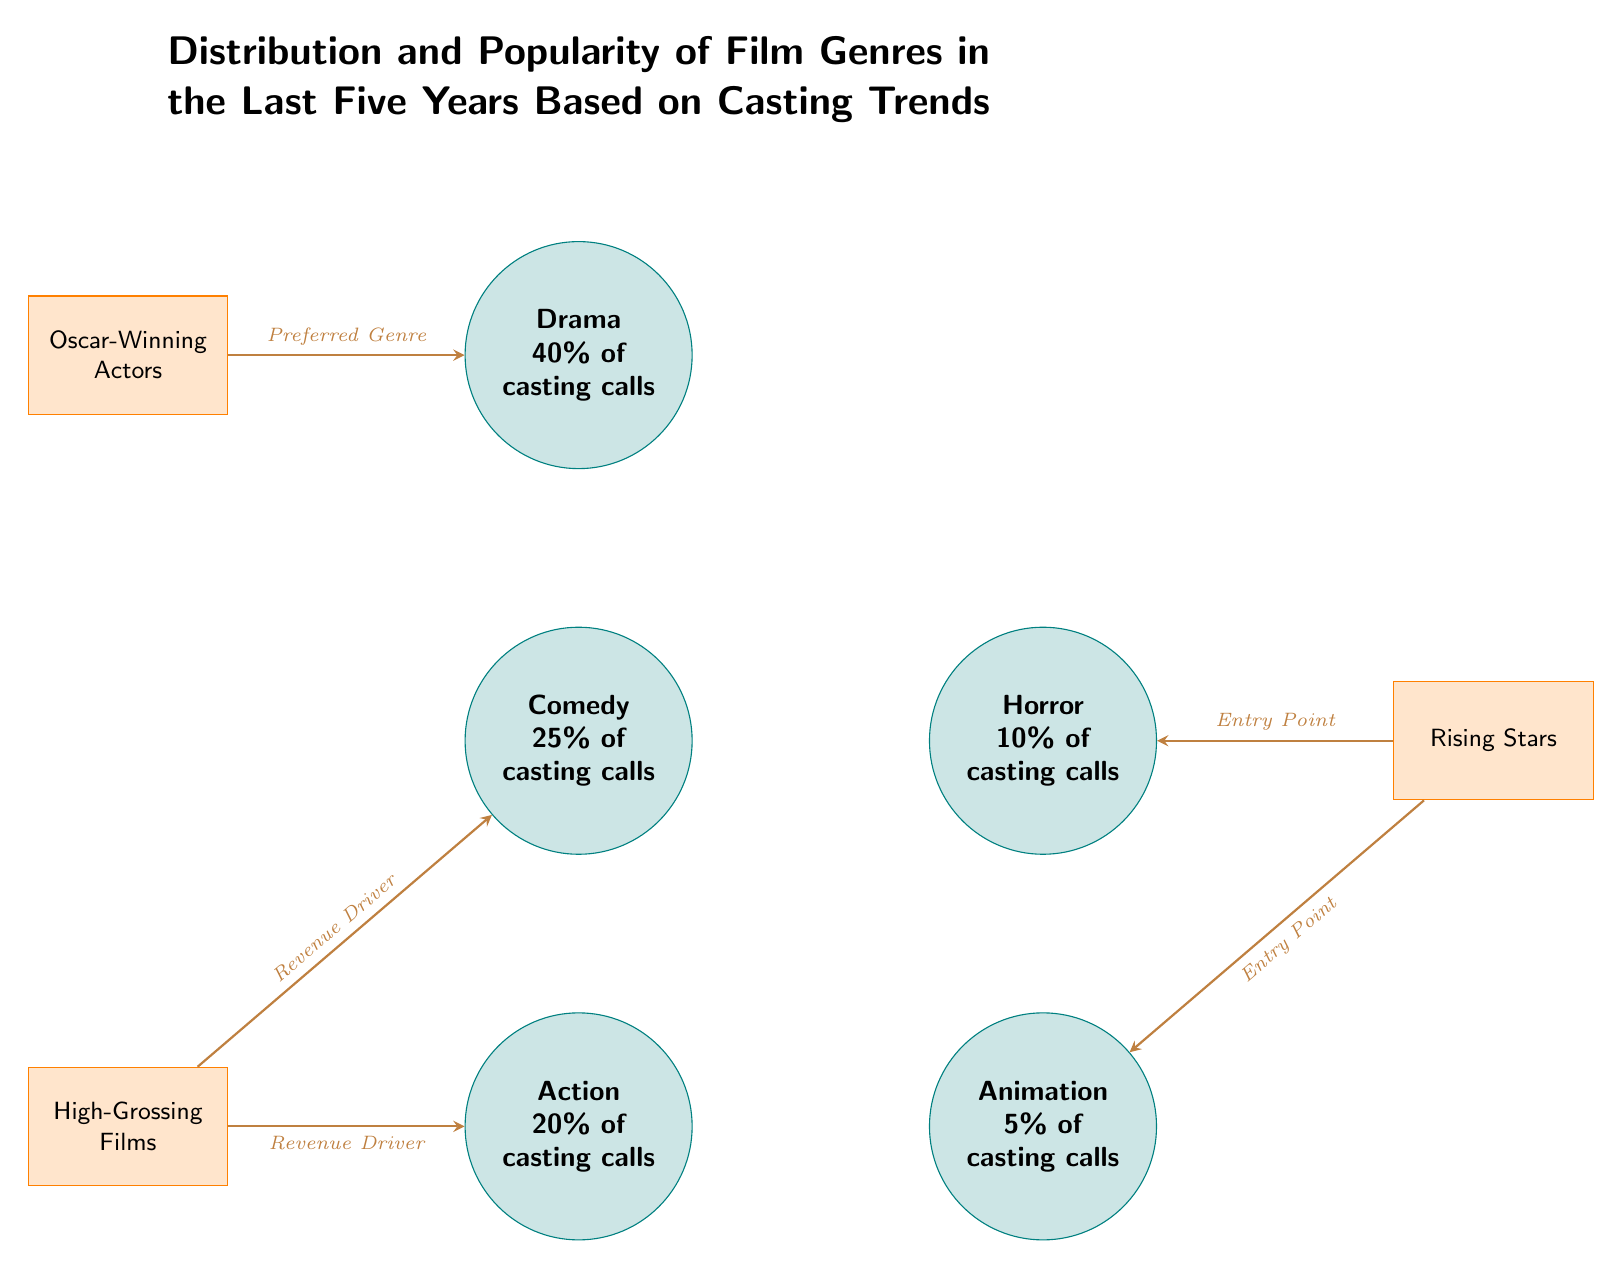What genre has the highest percentage of casting calls? The diagram explicitly states that Drama encompasses 40% of the casting calls, which is the highest value presented among the genres.
Answer: Drama What is the percentage of casting calls for Animation? According to the visual information in the diagram, Animation represents 5% of the casting calls, as indicated in its node.
Answer: 5% How many genres are represented in the diagram? The diagram lists five distinct genres: Drama, Comedy, Action, Horror, and Animation. Counting these gives a total of five genres.
Answer: 5 What is the primary revenue driver for the Action genre? The arrow leading from High-Grossing Films to Action specifies that this is the essential revenue driver for that genre, indicating a direct relationship.
Answer: Revenue Driver Which factor is linked to the Drama genre? The diagram shows that Oscar-Winning Actors are linked to Drama, as the arrow from that factor points directly towards the Drama node.
Answer: Oscar-Winning Actors What genres do Rising Stars serve as an entry point for? The diagram illustrates that Rising Stars connect to two genres: Horror and Animation, highlighting them as entry points for these categories.
Answer: Horror and Animation What is the second most popular genre based on casting calls? Based on the percentages indicated, Comedy, which accounts for 25% of casting calls, ranks as the second most popular genre after Drama.
Answer: Comedy How does High-Grossing Films influence Comedy? High-Grossing Films have a direct influence on Comedy as shown by the arrow leading from it to the Comedy genre, indicating that it also acts as a revenue driver for this genre.
Answer: Revenue Driver What is the overall trend in casting calls over the last five years? The diagram emphasizes the distribution of film genres in casting calls, showing a varied interest in different genres, with Drama being predominant, which suggests a shift towards more serious narratives.
Answer: Drama Predominance 